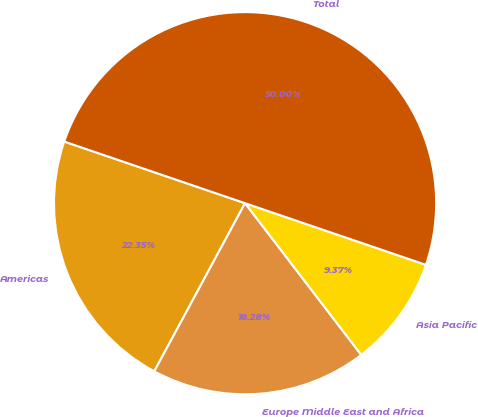<chart> <loc_0><loc_0><loc_500><loc_500><pie_chart><fcel>Americas<fcel>Europe Middle East and Africa<fcel>Asia Pacific<fcel>Total<nl><fcel>22.35%<fcel>18.28%<fcel>9.37%<fcel>50.0%<nl></chart> 